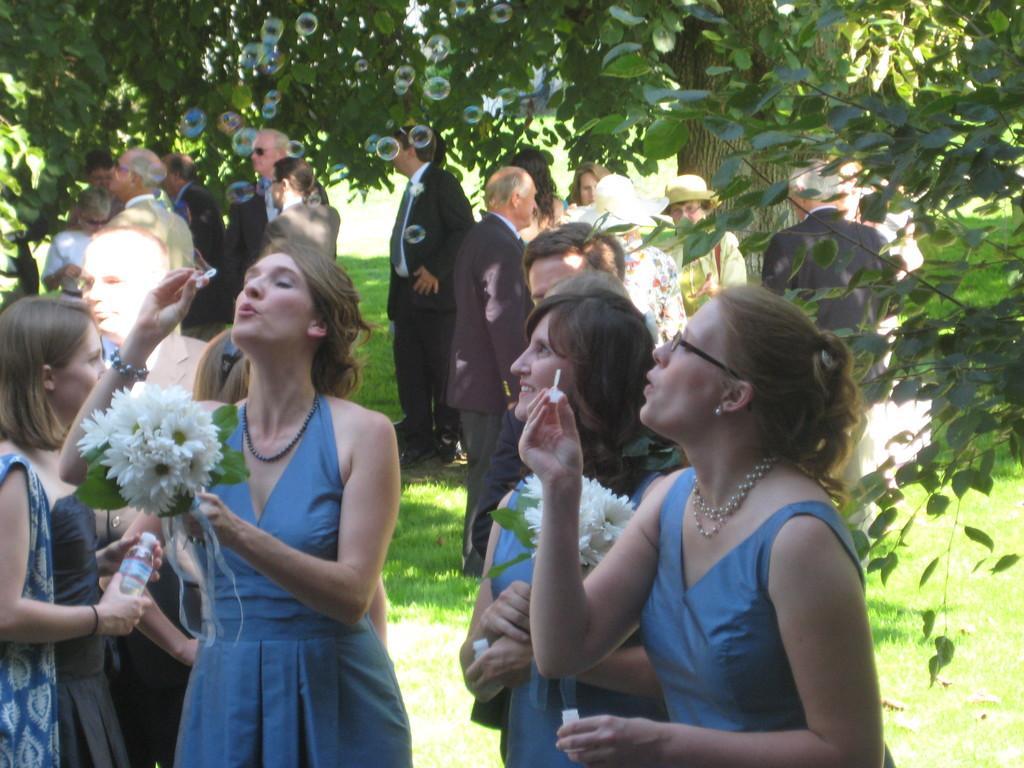In one or two sentences, can you explain what this image depicts? In this picture we can observe a woman standing wearing blue color dresses. Some of them were holding white color flowers in their hands. There are men and women in this picture. We can observe some grass on the ground. In the background there are trees. 